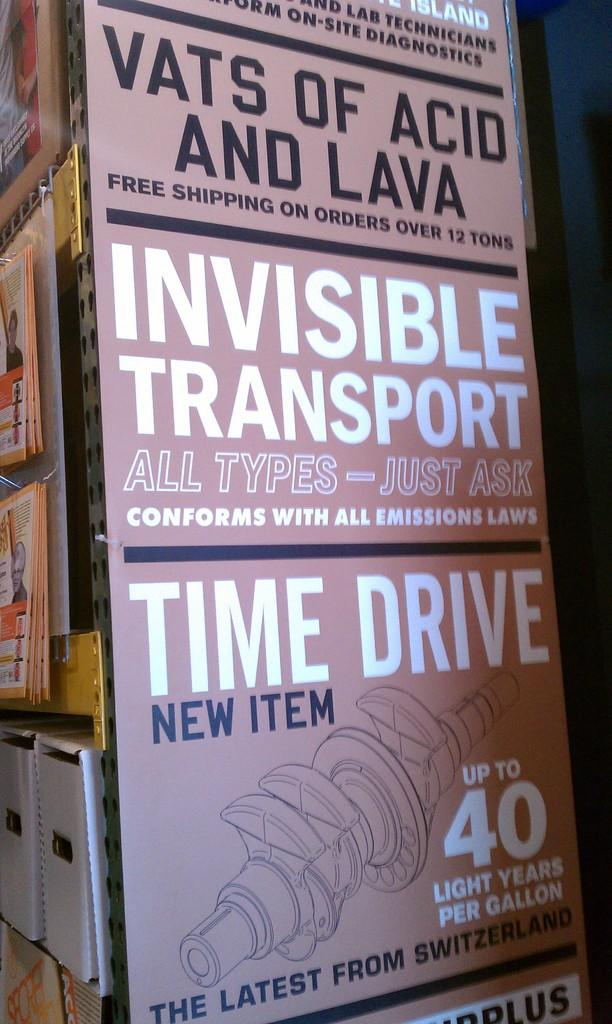Provide a one-sentence caption for the provided image. The end store isle with an advertisement of Invisible Transport. 